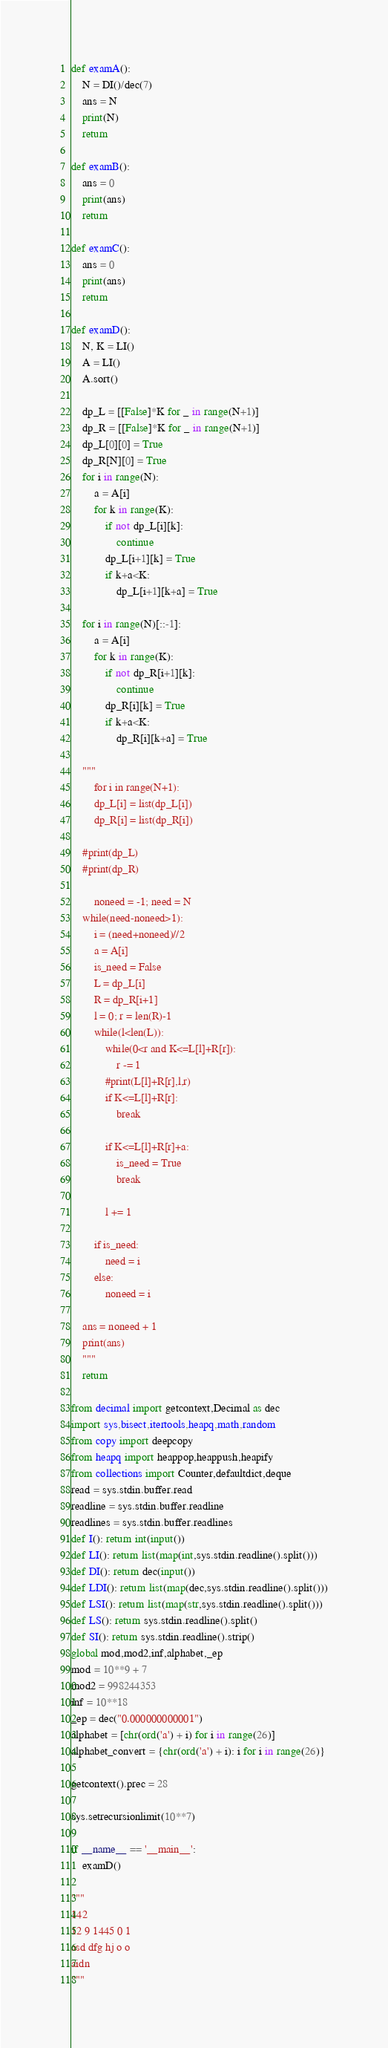<code> <loc_0><loc_0><loc_500><loc_500><_Python_>def examA():
    N = DI()/dec(7)
    ans = N
    print(N)
    return

def examB():
    ans = 0
    print(ans)
    return

def examC():
    ans = 0
    print(ans)
    return

def examD():
    N, K = LI()
    A = LI()
    A.sort()

    dp_L = [[False]*K for _ in range(N+1)]
    dp_R = [[False]*K for _ in range(N+1)]
    dp_L[0][0] = True
    dp_R[N][0] = True
    for i in range(N):
        a = A[i]
        for k in range(K):
            if not dp_L[i][k]:
                continue
            dp_L[i+1][k] = True
            if k+a<K:
                dp_L[i+1][k+a] = True

    for i in range(N)[::-1]:
        a = A[i]
        for k in range(K):
            if not dp_R[i+1][k]:
                continue
            dp_R[i][k] = True
            if k+a<K:
                dp_R[i][k+a] = True

    """
        for i in range(N+1):
        dp_L[i] = list(dp_L[i])
        dp_R[i] = list(dp_R[i])

    #print(dp_L)
    #print(dp_R)
    
        noneed = -1; need = N
    while(need-noneed>1):
        i = (need+noneed)//2
        a = A[i]
        is_need = False
        L = dp_L[i]
        R = dp_R[i+1]
        l = 0; r = len(R)-1
        while(l<len(L)):
            while(0<r and K<=L[l]+R[r]):
                r -= 1
            #print(L[l]+R[r],l,r)
            if K<=L[l]+R[r]:
                break

            if K<=L[l]+R[r]+a:
                is_need = True
                break

            l += 1

        if is_need:
            need = i
        else:
            noneed = i

    ans = noneed + 1
    print(ans)
    """
    return

from decimal import getcontext,Decimal as dec
import sys,bisect,itertools,heapq,math,random
from copy import deepcopy
from heapq import heappop,heappush,heapify
from collections import Counter,defaultdict,deque
read = sys.stdin.buffer.read
readline = sys.stdin.buffer.readline
readlines = sys.stdin.buffer.readlines
def I(): return int(input())
def LI(): return list(map(int,sys.stdin.readline().split()))
def DI(): return dec(input())
def LDI(): return list(map(dec,sys.stdin.readline().split()))
def LSI(): return list(map(str,sys.stdin.readline().split()))
def LS(): return sys.stdin.readline().split()
def SI(): return sys.stdin.readline().strip()
global mod,mod2,inf,alphabet,_ep
mod = 10**9 + 7
mod2 = 998244353
inf = 10**18
_ep = dec("0.000000000001")
alphabet = [chr(ord('a') + i) for i in range(26)]
alphabet_convert = {chr(ord('a') + i): i for i in range(26)}

getcontext().prec = 28

sys.setrecursionlimit(10**7)

if __name__ == '__main__':
    examD()

"""
142
12 9 1445 0 1
asd dfg hj o o
aidn
"""</code> 